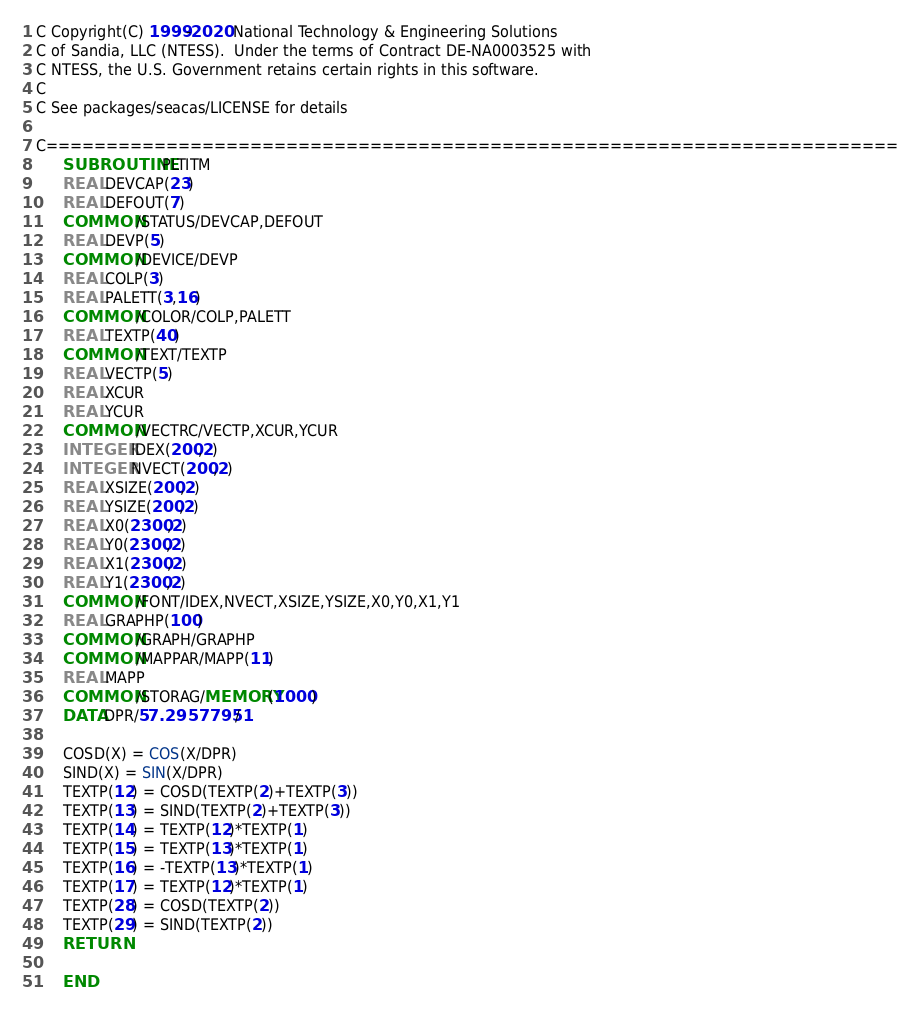Convert code to text. <code><loc_0><loc_0><loc_500><loc_500><_FORTRAN_>C Copyright(C) 1999-2020 National Technology & Engineering Solutions
C of Sandia, LLC (NTESS).  Under the terms of Contract DE-NA0003525 with
C NTESS, the U.S. Government retains certain rights in this software.
C
C See packages/seacas/LICENSE for details

C=======================================================================
      SUBROUTINE PLTITM
      REAL DEVCAP(23)
      REAL DEFOUT(7)
      COMMON /STATUS/DEVCAP,DEFOUT
      REAL DEVP(5)
      COMMON /DEVICE/DEVP
      REAL COLP(3)
      REAL PALETT(3,16)
      COMMON /COLOR/COLP,PALETT
      REAL TEXTP(40)
      COMMON /TEXT/TEXTP
      REAL VECTP(5)
      REAL XCUR
      REAL YCUR
      COMMON /VECTRC/VECTP,XCUR,YCUR
      INTEGER IDEX(200,2)
      INTEGER NVECT(200,2)
      REAL XSIZE(200,2)
      REAL YSIZE(200,2)
      REAL X0(2300,2)
      REAL Y0(2300,2)
      REAL X1(2300,2)
      REAL Y1(2300,2)
      COMMON /FONT/IDEX,NVECT,XSIZE,YSIZE,X0,Y0,X1,Y1
      REAL GRAPHP(100)
      COMMON /GRAPH/GRAPHP
      COMMON /MAPPAR/MAPP(11)
      REAL MAPP
      COMMON /STORAG/MEMORY(1000)
      DATA DPR/57.29577951/

      COSD(X) = COS(X/DPR)
      SIND(X) = SIN(X/DPR)
      TEXTP(12) = COSD(TEXTP(2)+TEXTP(3))
      TEXTP(13) = SIND(TEXTP(2)+TEXTP(3))
      TEXTP(14) = TEXTP(12)*TEXTP(1)
      TEXTP(15) = TEXTP(13)*TEXTP(1)
      TEXTP(16) = -TEXTP(13)*TEXTP(1)
      TEXTP(17) = TEXTP(12)*TEXTP(1)
      TEXTP(28) = COSD(TEXTP(2))
      TEXTP(29) = SIND(TEXTP(2))
      RETURN

      END
</code> 